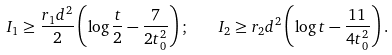Convert formula to latex. <formula><loc_0><loc_0><loc_500><loc_500>I _ { 1 } \geq \frac { r _ { 1 } d ^ { 2 } } { 2 } \left ( \log \frac { t } { 2 } - \frac { 7 } { 2 t _ { 0 } ^ { 2 } } \right ) ; \quad I _ { 2 } \geq r _ { 2 } d ^ { 2 } \left ( \log t - \frac { 1 1 } { 4 t _ { 0 } ^ { 2 } } \right ) .</formula> 